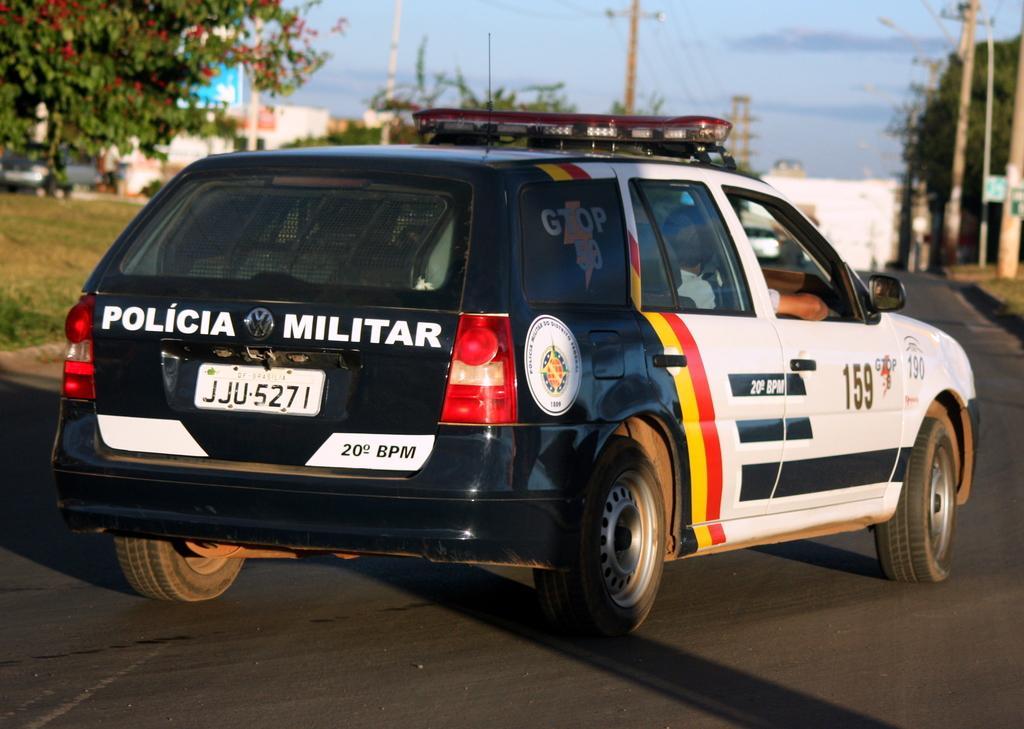Please provide a concise description of this image. In front of the image there is a police car on the road, on the either side of the road there are lamp posts, trees, buildings and billboards, in the sky there are clouds, on the electric poles there are cables. 